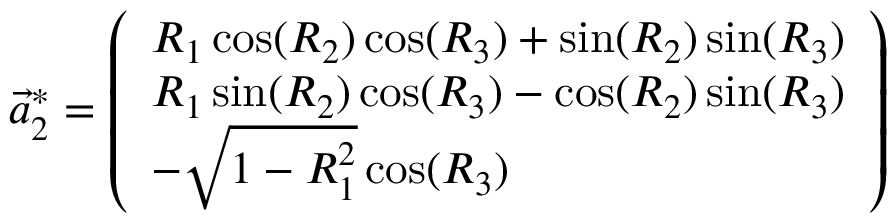<formula> <loc_0><loc_0><loc_500><loc_500>\vec { a } _ { 2 } ^ { * } = \left ( \begin{array} { l } { R _ { 1 } \cos ( R _ { 2 } ) \cos ( R _ { 3 } ) + \sin ( R _ { 2 } ) \sin ( R _ { 3 } ) } \\ { R _ { 1 } \sin ( R _ { 2 } ) \cos ( R _ { 3 } ) - \cos ( R _ { 2 } ) \sin ( R _ { 3 } ) } \\ { - \sqrt { 1 - R _ { 1 } ^ { 2 } } \cos ( R _ { 3 } ) } \end{array} \right )</formula> 